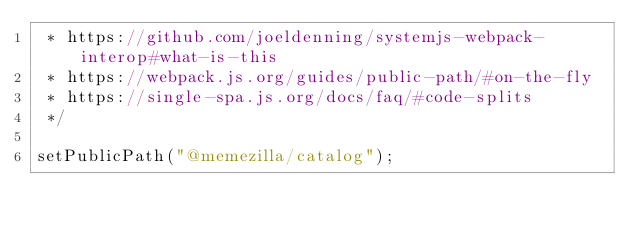<code> <loc_0><loc_0><loc_500><loc_500><_TypeScript_> * https://github.com/joeldenning/systemjs-webpack-interop#what-is-this
 * https://webpack.js.org/guides/public-path/#on-the-fly
 * https://single-spa.js.org/docs/faq/#code-splits
 */

setPublicPath("@memezilla/catalog");
</code> 